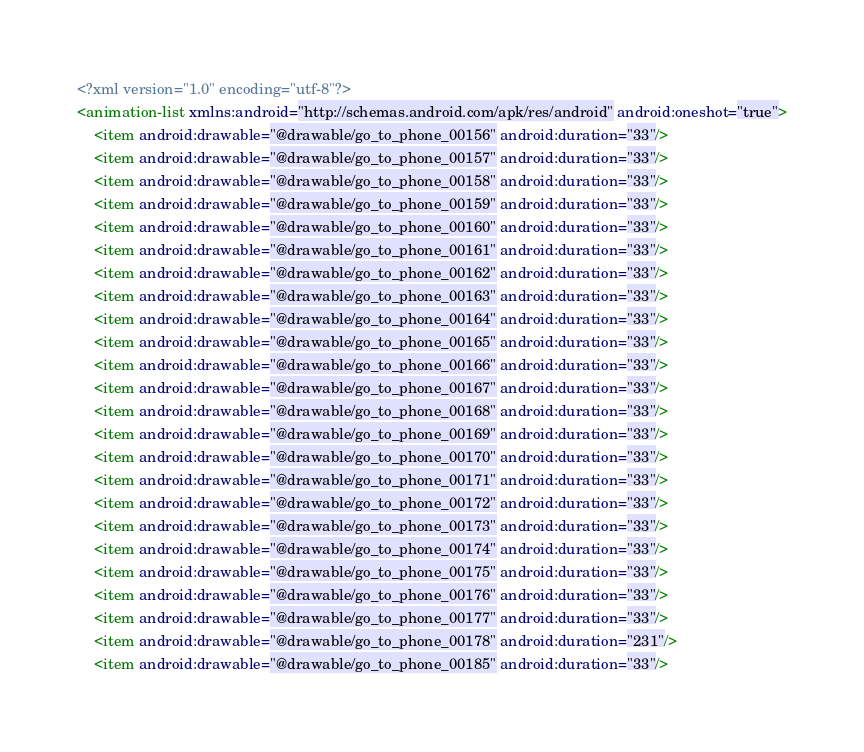<code> <loc_0><loc_0><loc_500><loc_500><_XML_><?xml version="1.0" encoding="utf-8"?>
<animation-list xmlns:android="http://schemas.android.com/apk/res/android" android:oneshot="true">
    <item android:drawable="@drawable/go_to_phone_00156" android:duration="33"/>
    <item android:drawable="@drawable/go_to_phone_00157" android:duration="33"/>
    <item android:drawable="@drawable/go_to_phone_00158" android:duration="33"/>
    <item android:drawable="@drawable/go_to_phone_00159" android:duration="33"/>
    <item android:drawable="@drawable/go_to_phone_00160" android:duration="33"/>
    <item android:drawable="@drawable/go_to_phone_00161" android:duration="33"/>
    <item android:drawable="@drawable/go_to_phone_00162" android:duration="33"/>
    <item android:drawable="@drawable/go_to_phone_00163" android:duration="33"/>
    <item android:drawable="@drawable/go_to_phone_00164" android:duration="33"/>
    <item android:drawable="@drawable/go_to_phone_00165" android:duration="33"/>
    <item android:drawable="@drawable/go_to_phone_00166" android:duration="33"/>
    <item android:drawable="@drawable/go_to_phone_00167" android:duration="33"/>
    <item android:drawable="@drawable/go_to_phone_00168" android:duration="33"/>
    <item android:drawable="@drawable/go_to_phone_00169" android:duration="33"/>
    <item android:drawable="@drawable/go_to_phone_00170" android:duration="33"/>
    <item android:drawable="@drawable/go_to_phone_00171" android:duration="33"/>
    <item android:drawable="@drawable/go_to_phone_00172" android:duration="33"/>
    <item android:drawable="@drawable/go_to_phone_00173" android:duration="33"/>
    <item android:drawable="@drawable/go_to_phone_00174" android:duration="33"/>
    <item android:drawable="@drawable/go_to_phone_00175" android:duration="33"/>
    <item android:drawable="@drawable/go_to_phone_00176" android:duration="33"/>
    <item android:drawable="@drawable/go_to_phone_00177" android:duration="33"/>
    <item android:drawable="@drawable/go_to_phone_00178" android:duration="231"/>
    <item android:drawable="@drawable/go_to_phone_00185" android:duration="33"/></code> 